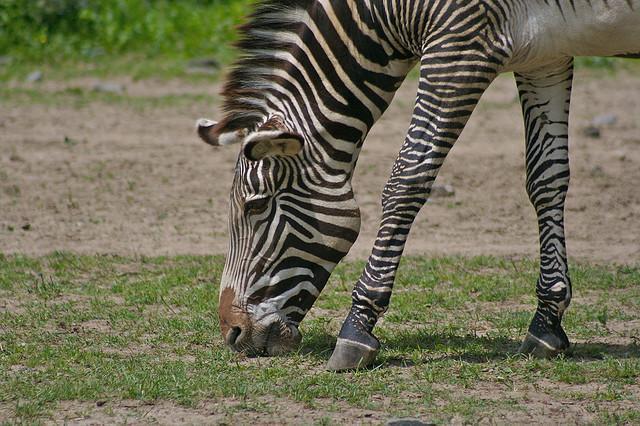How many animals in this photo?
Give a very brief answer. 1. How many hooves are visible?
Give a very brief answer. 2. 